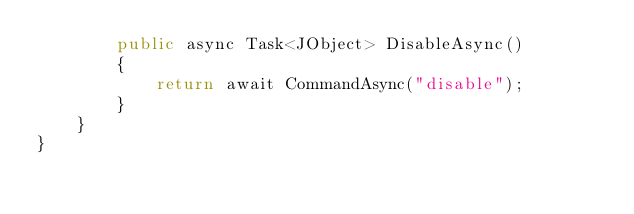<code> <loc_0><loc_0><loc_500><loc_500><_C#_>        public async Task<JObject> DisableAsync()
        {
            return await CommandAsync("disable");
        }
    }
}
</code> 